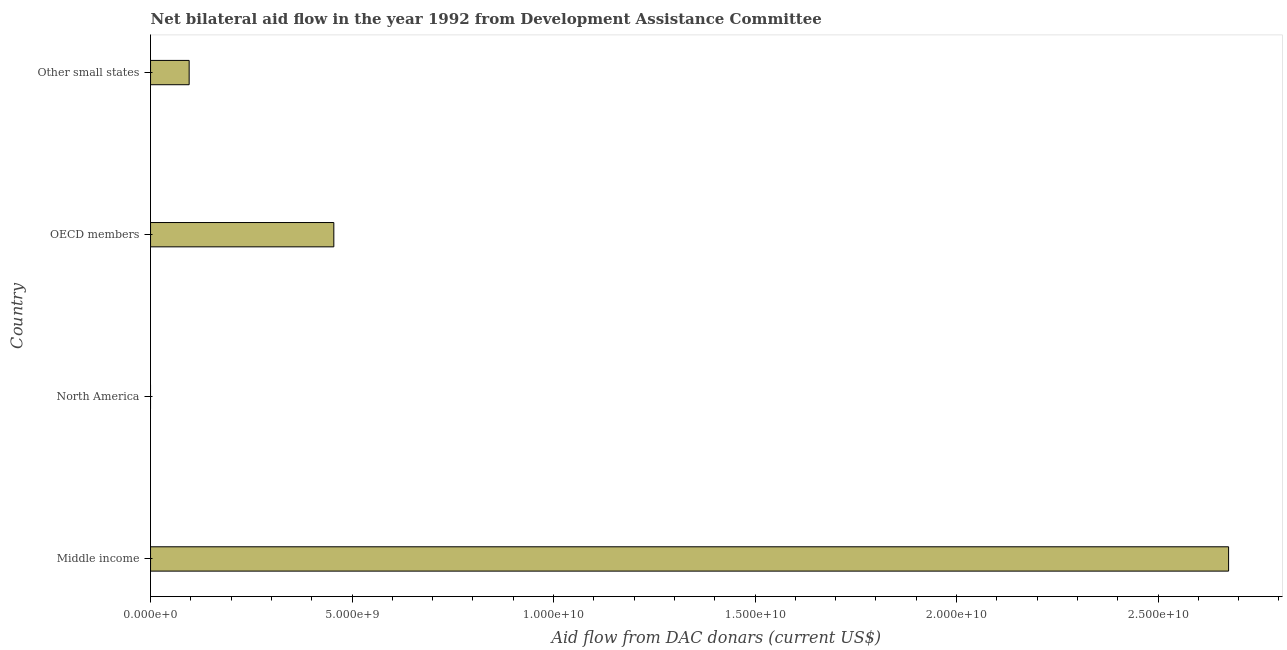Does the graph contain any zero values?
Offer a terse response. Yes. What is the title of the graph?
Give a very brief answer. Net bilateral aid flow in the year 1992 from Development Assistance Committee. What is the label or title of the X-axis?
Provide a succinct answer. Aid flow from DAC donars (current US$). Across all countries, what is the maximum net bilateral aid flows from dac donors?
Ensure brevity in your answer.  2.68e+1. What is the sum of the net bilateral aid flows from dac donors?
Give a very brief answer. 3.23e+1. What is the difference between the net bilateral aid flows from dac donors in Middle income and OECD members?
Your answer should be very brief. 2.22e+1. What is the average net bilateral aid flows from dac donors per country?
Provide a short and direct response. 8.06e+09. What is the median net bilateral aid flows from dac donors?
Provide a succinct answer. 2.75e+09. In how many countries, is the net bilateral aid flows from dac donors greater than 15000000000 US$?
Offer a terse response. 1. What is the ratio of the net bilateral aid flows from dac donors in Middle income to that in Other small states?
Provide a succinct answer. 27.91. What is the difference between the highest and the second highest net bilateral aid flows from dac donors?
Your answer should be compact. 2.22e+1. Is the sum of the net bilateral aid flows from dac donors in OECD members and Other small states greater than the maximum net bilateral aid flows from dac donors across all countries?
Your answer should be compact. No. What is the difference between the highest and the lowest net bilateral aid flows from dac donors?
Provide a short and direct response. 2.68e+1. In how many countries, is the net bilateral aid flows from dac donors greater than the average net bilateral aid flows from dac donors taken over all countries?
Your answer should be very brief. 1. How many bars are there?
Provide a short and direct response. 3. Are all the bars in the graph horizontal?
Your answer should be very brief. Yes. Are the values on the major ticks of X-axis written in scientific E-notation?
Your answer should be compact. Yes. What is the Aid flow from DAC donars (current US$) in Middle income?
Provide a short and direct response. 2.68e+1. What is the Aid flow from DAC donars (current US$) in North America?
Offer a very short reply. 0. What is the Aid flow from DAC donars (current US$) of OECD members?
Your answer should be compact. 4.55e+09. What is the Aid flow from DAC donars (current US$) of Other small states?
Offer a terse response. 9.58e+08. What is the difference between the Aid flow from DAC donars (current US$) in Middle income and OECD members?
Your answer should be compact. 2.22e+1. What is the difference between the Aid flow from DAC donars (current US$) in Middle income and Other small states?
Your response must be concise. 2.58e+1. What is the difference between the Aid flow from DAC donars (current US$) in OECD members and Other small states?
Your answer should be very brief. 3.59e+09. What is the ratio of the Aid flow from DAC donars (current US$) in Middle income to that in OECD members?
Provide a short and direct response. 5.88. What is the ratio of the Aid flow from DAC donars (current US$) in Middle income to that in Other small states?
Provide a succinct answer. 27.91. What is the ratio of the Aid flow from DAC donars (current US$) in OECD members to that in Other small states?
Provide a succinct answer. 4.75. 